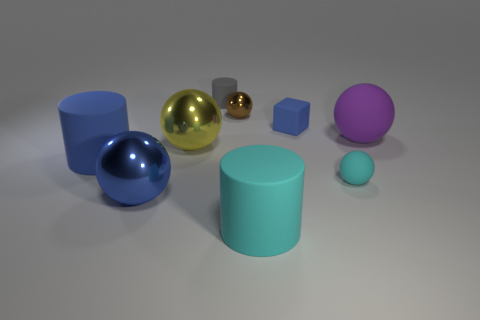Subtract 1 cylinders. How many cylinders are left? 2 Subtract all purple balls. How many balls are left? 4 Subtract all large purple spheres. How many spheres are left? 4 Add 1 large cylinders. How many objects exist? 10 Subtract all red spheres. Subtract all brown cylinders. How many spheres are left? 5 Subtract all blocks. How many objects are left? 8 Subtract all tiny objects. Subtract all tiny blue things. How many objects are left? 4 Add 8 blue blocks. How many blue blocks are left? 9 Add 4 blue matte things. How many blue matte things exist? 6 Subtract 1 blue cylinders. How many objects are left? 8 